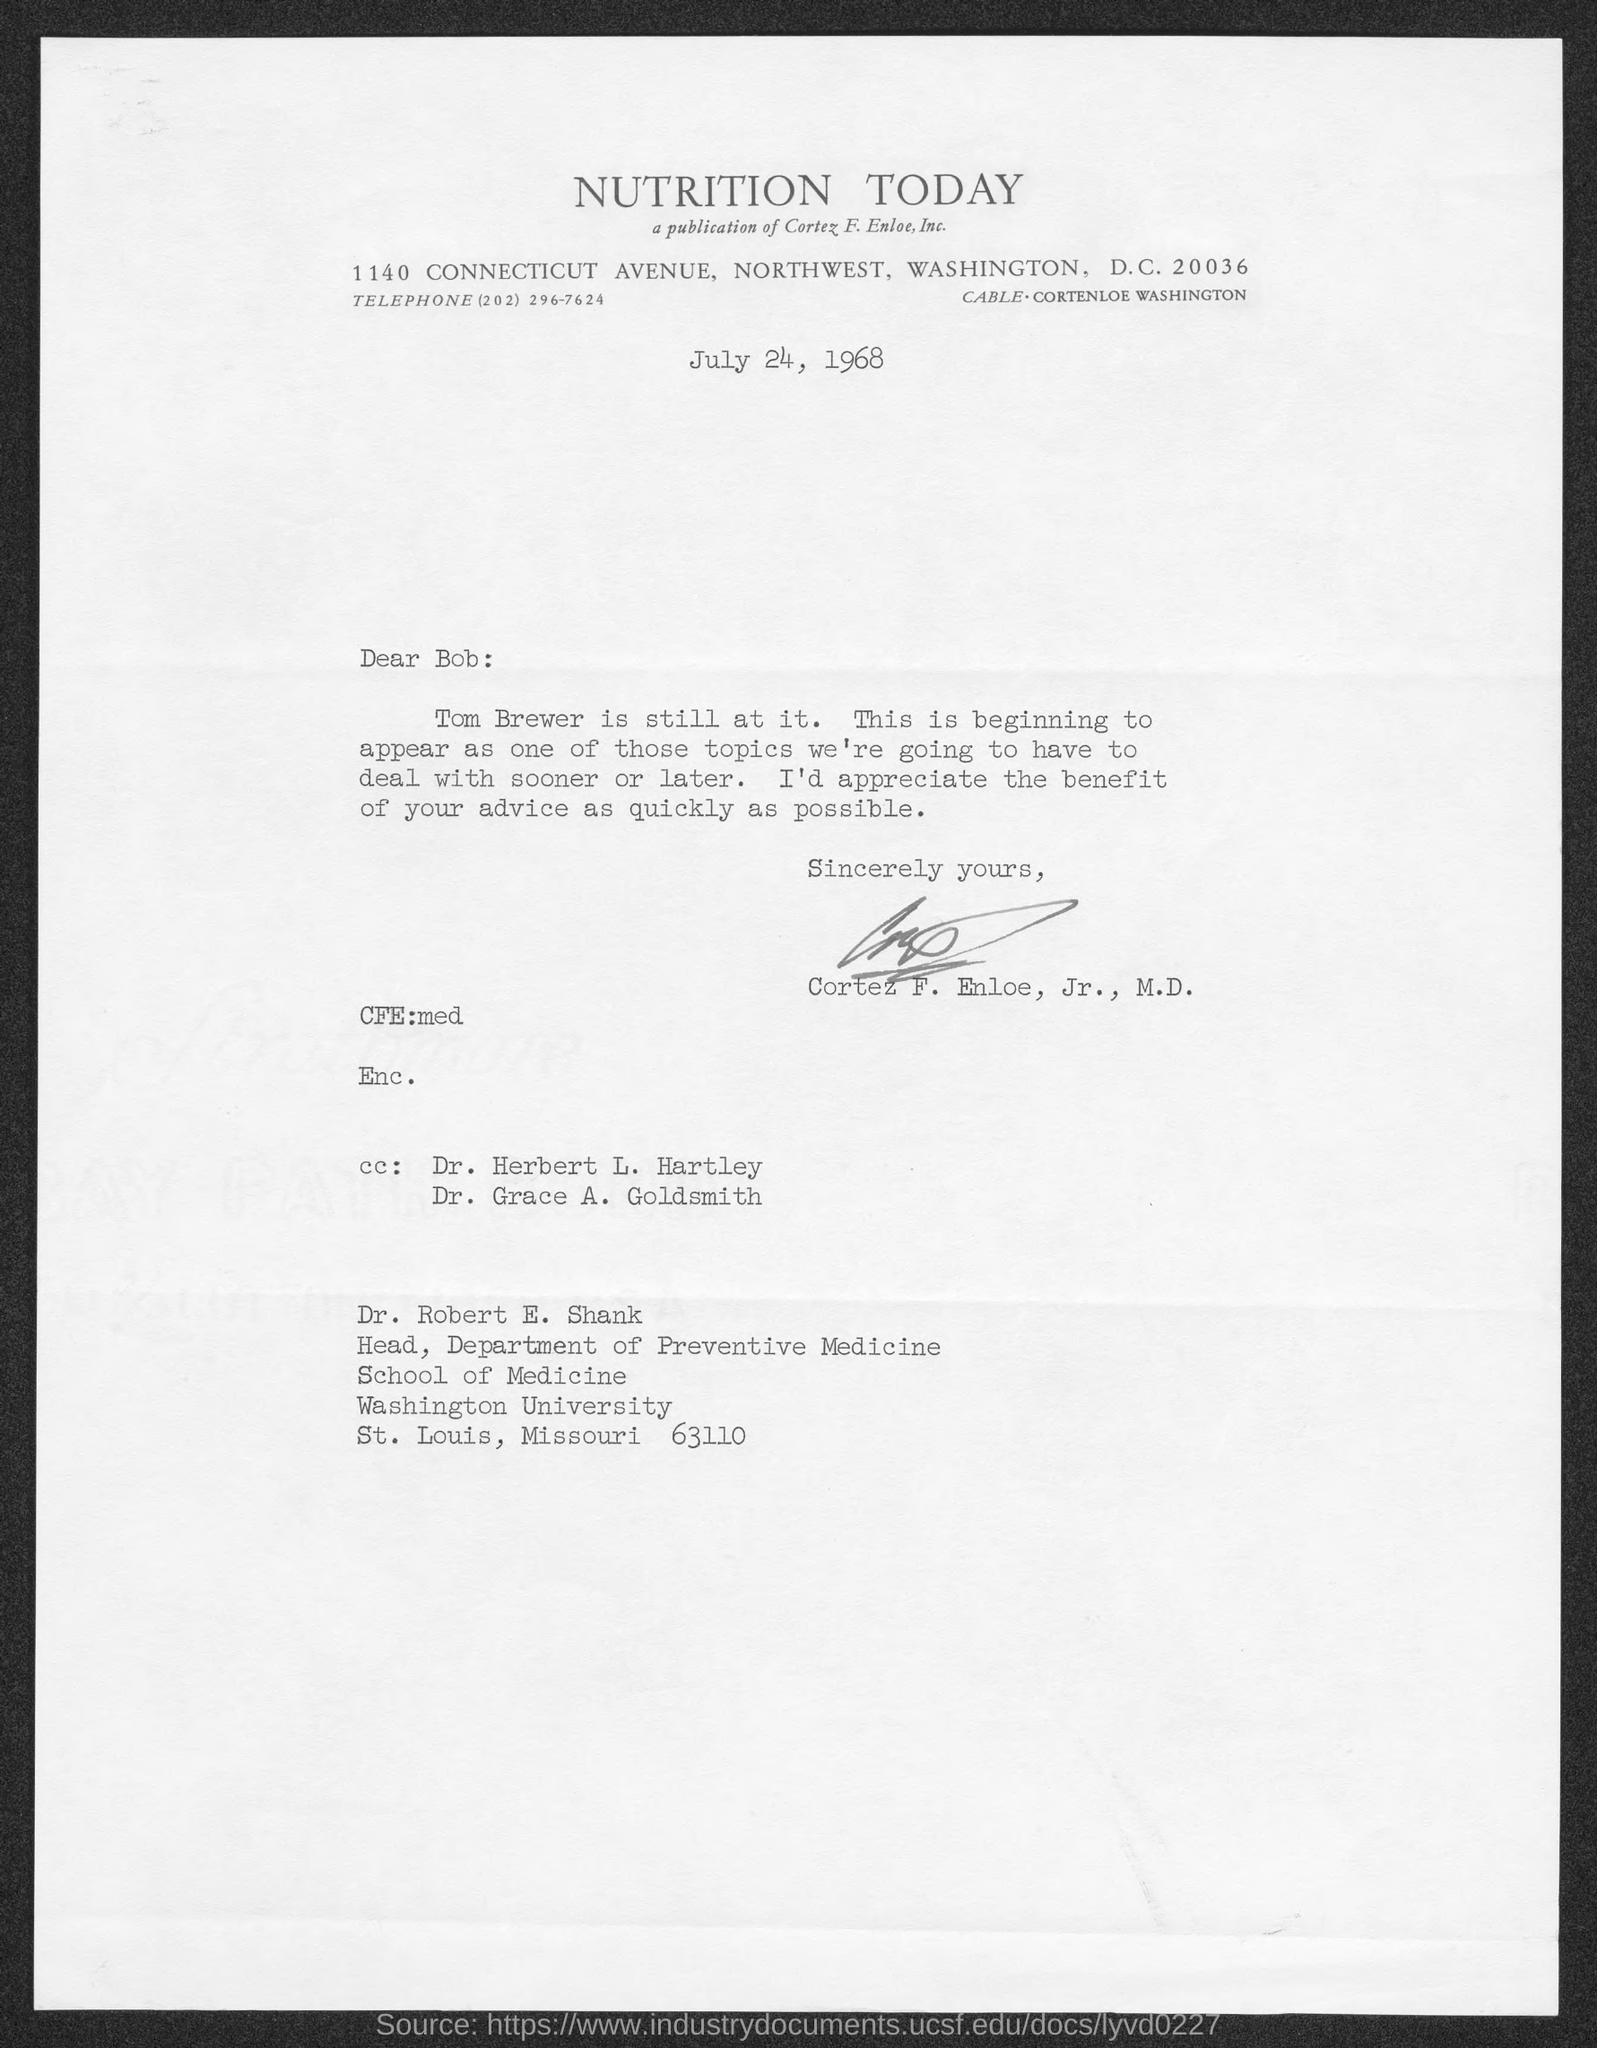Which Journal is mentioned in the letterhead?
Provide a short and direct response. NUTRITION TODAY. Who is the Head, Department of Preventive Medicines?
Ensure brevity in your answer.  Dr. Robert E. Shank. What is the date on which this letter is sent?
Provide a succinct answer. July 24, 1968. Who is this letter to?
Your answer should be compact. Dr. Robert E. Shank. Who has signed this letter?
Offer a very short reply. Cortez F. Enloe, Jr., M.D. 